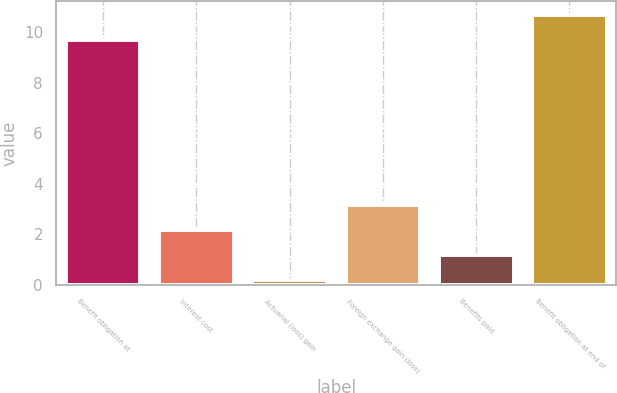Convert chart. <chart><loc_0><loc_0><loc_500><loc_500><bar_chart><fcel>Benefit obligation at<fcel>Interest cost<fcel>Actuarial (loss) gain<fcel>Foreign exchange gain (loss)<fcel>Benefits paid<fcel>Benefit obligation at end of<nl><fcel>9.7<fcel>2.18<fcel>0.2<fcel>3.17<fcel>1.19<fcel>10.69<nl></chart> 